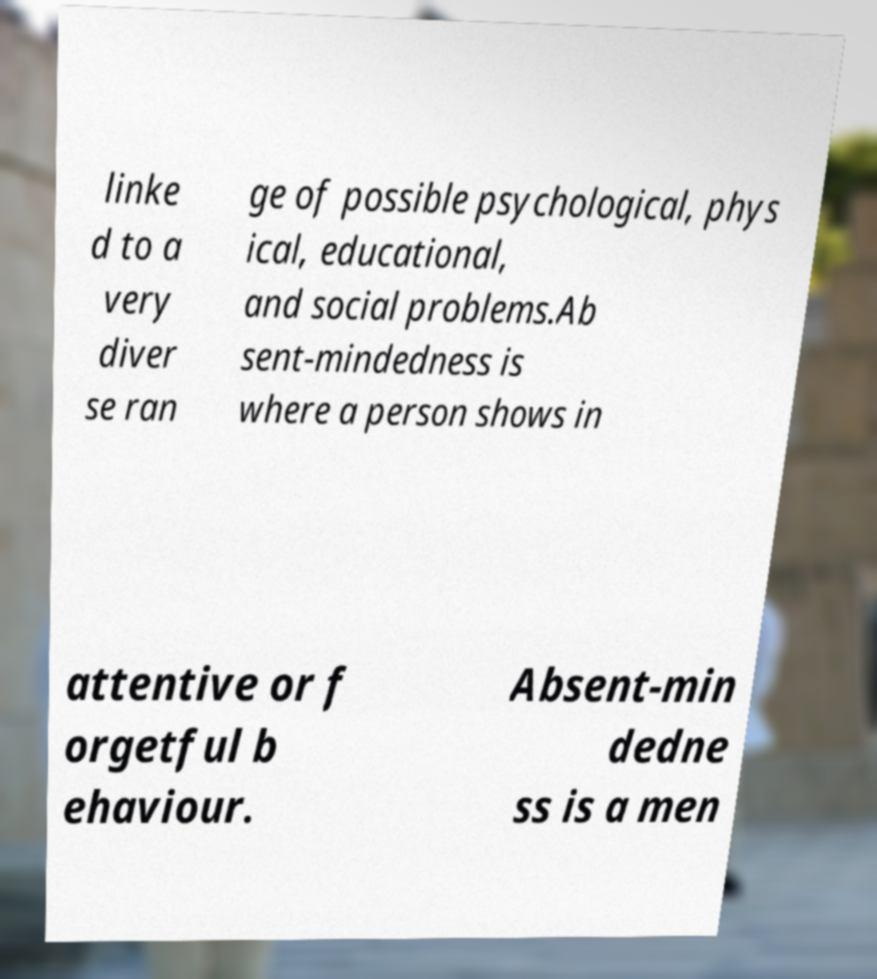Could you assist in decoding the text presented in this image and type it out clearly? linke d to a very diver se ran ge of possible psychological, phys ical, educational, and social problems.Ab sent-mindedness is where a person shows in attentive or f orgetful b ehaviour. Absent-min dedne ss is a men 